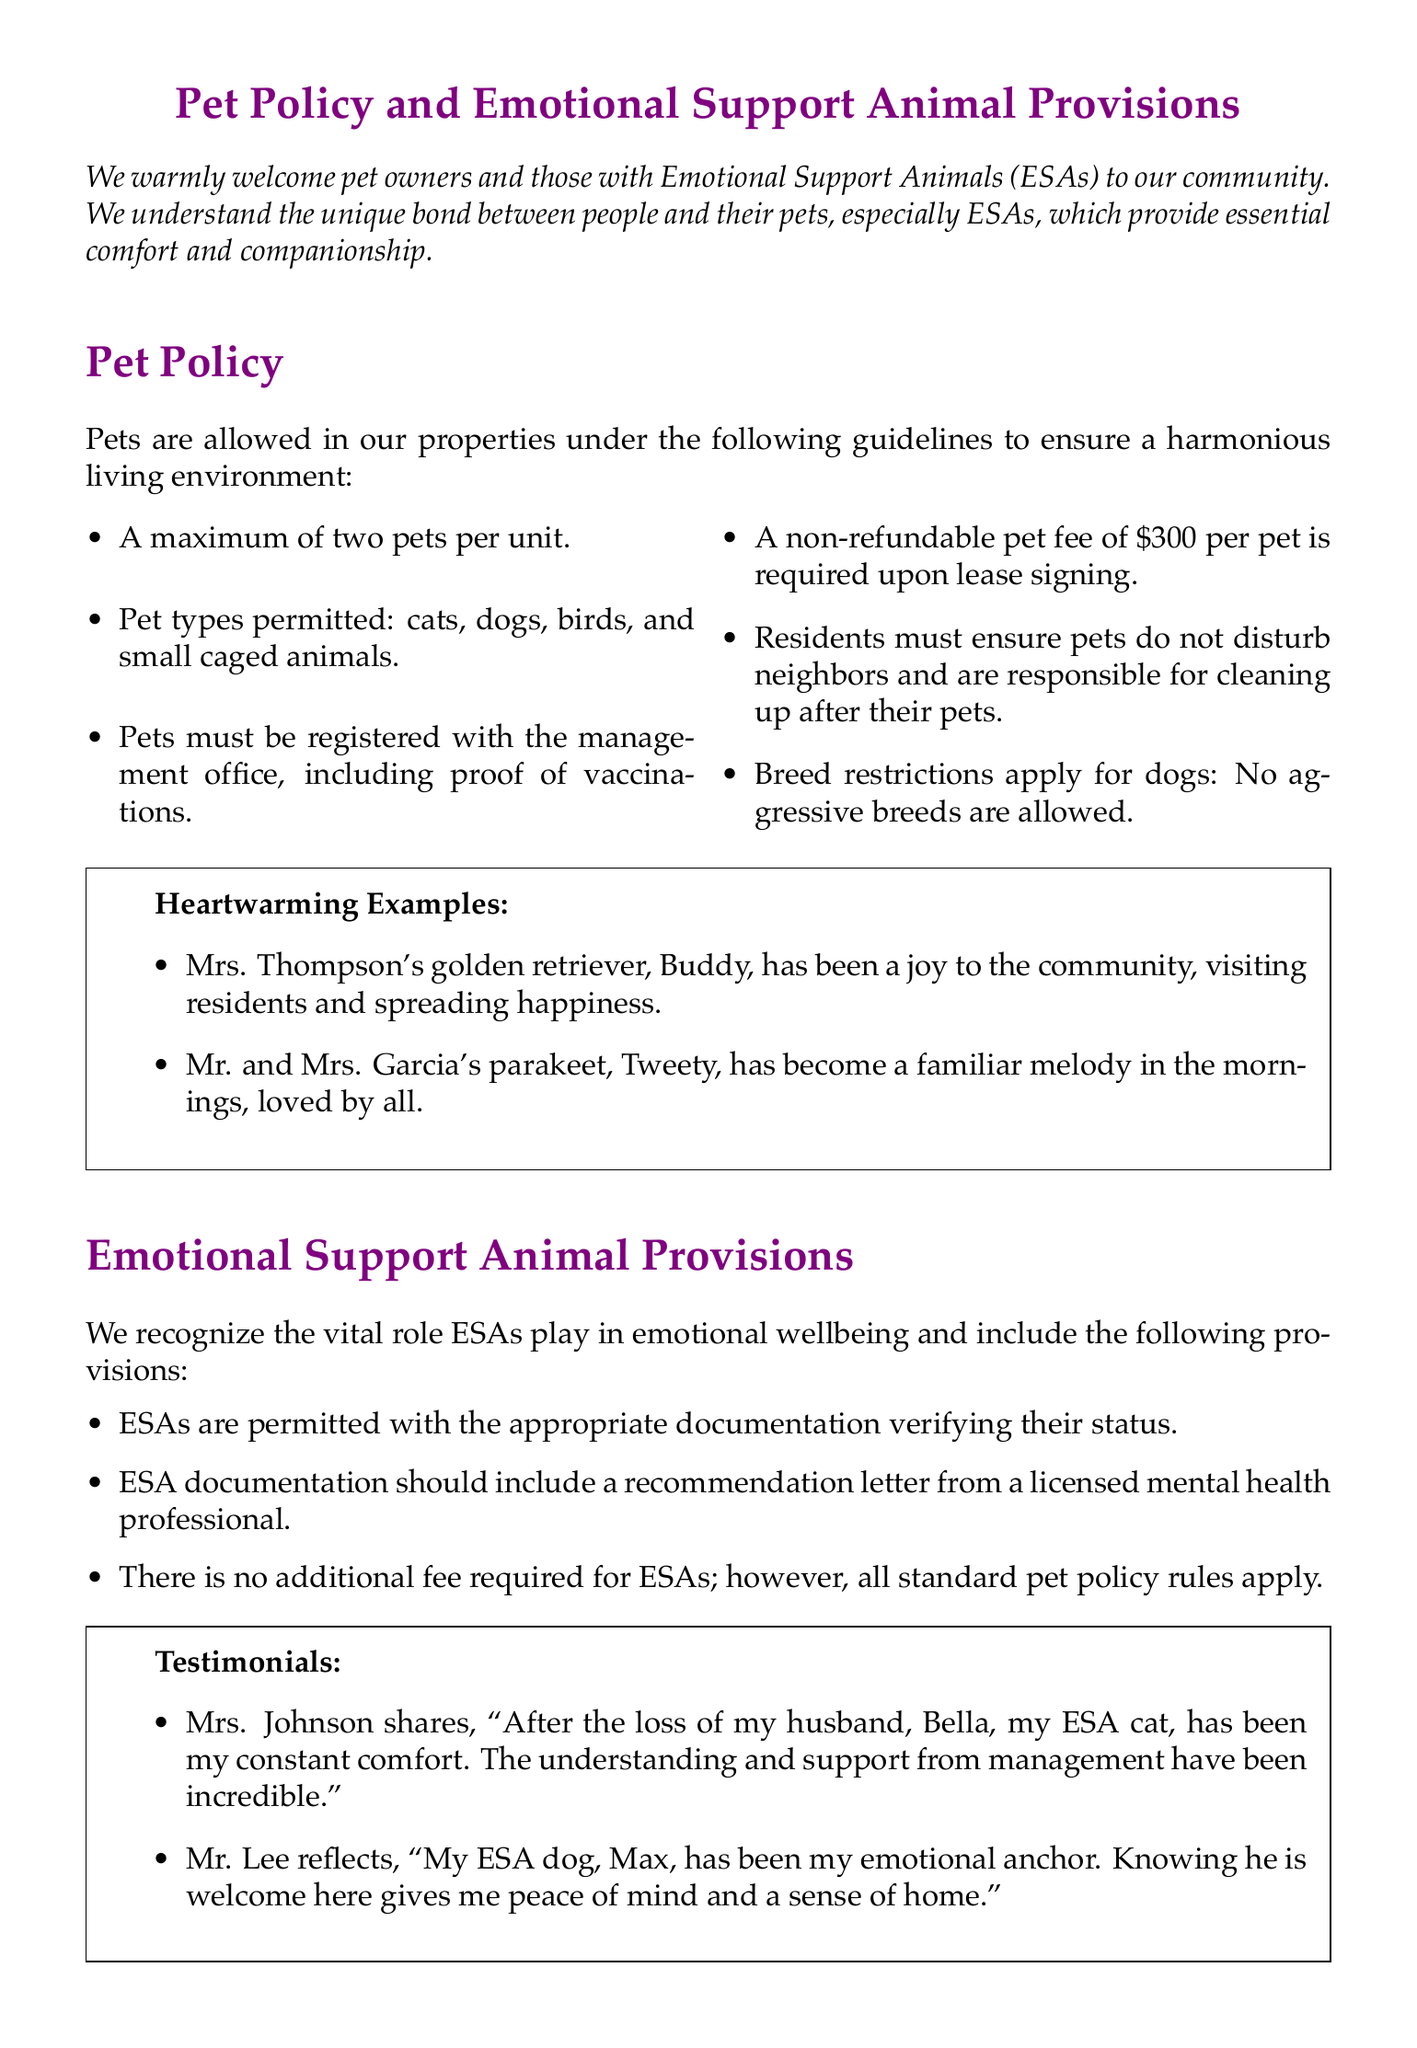What is the maximum number of pets allowed per unit? The document states a maximum of two pets are allowed per unit.
Answer: two What type of pets are permitted? The document lists the types of pets permitted: cats, dogs, birds, and small caged animals.
Answer: cats, dogs, birds, small caged animals Is there an additional fee for Emotional Support Animals? The provisions mention that there is no additional fee required for ESAs.
Answer: no What is the non-refundable pet fee per pet? The document specifies a non-refundable pet fee of $300 per pet.
Answer: $300 Who must provide the ESA documentation? The documentation must be provided by a licensed mental health professional.
Answer: licensed mental health professional What breed types are restricted for dogs? The document mentions that no aggressive breeds are allowed.
Answer: aggressive breeds What heartwarming example features a golden retriever? The document mentions Mrs. Thompson's golden retriever, Buddy, as a heartwarming example.
Answer: Buddy What does Mrs. Johnson's ESA provide her after her loss? Mrs. Johnson states that Bella, her ESA cat, has been her constant comfort.
Answer: comfort 